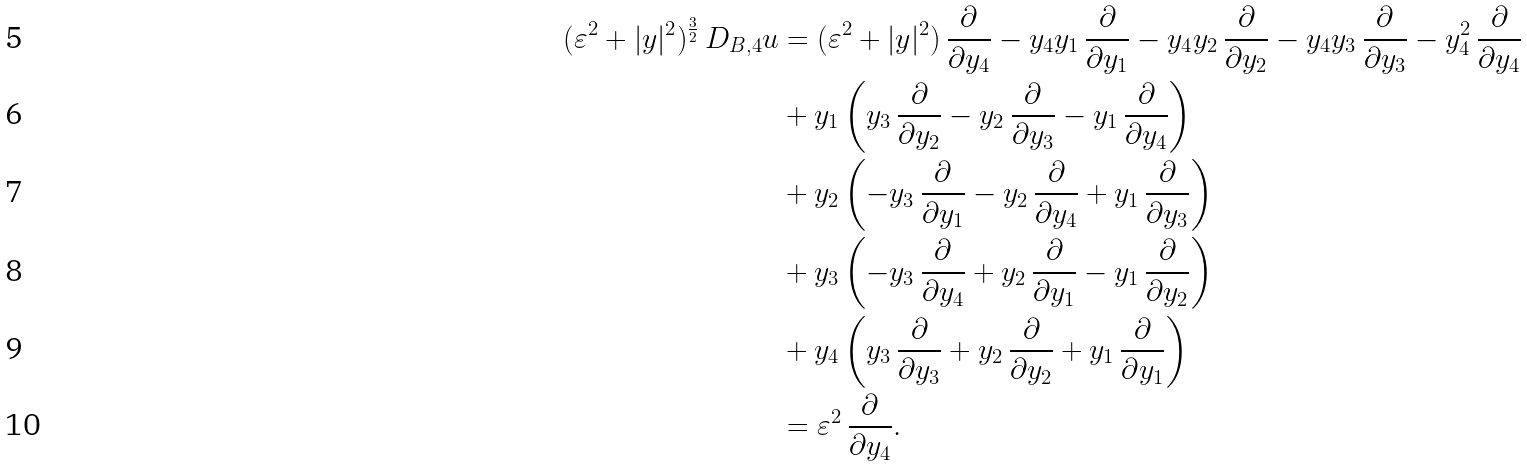Convert formula to latex. <formula><loc_0><loc_0><loc_500><loc_500>( \varepsilon ^ { 2 } + | y | ^ { 2 } ) ^ { \frac { 3 } { 2 } } \, D _ { B , 4 } u & = ( \varepsilon ^ { 2 } + | y | ^ { 2 } ) \, \frac { \partial } { \partial y _ { 4 } } - y _ { 4 } y _ { 1 } \, \frac { \partial } { \partial y _ { 1 } } - y _ { 4 } y _ { 2 } \, \frac { \partial } { \partial y _ { 2 } } - y _ { 4 } y _ { 3 } \, \frac { \partial } { \partial y _ { 3 } } - y _ { 4 } ^ { 2 } \, \frac { \partial } { \partial y _ { 4 } } \\ & + y _ { 1 } \left ( y _ { 3 } \, \frac { \partial } { \partial y _ { 2 } } - y _ { 2 } \, \frac { \partial } { \partial y _ { 3 } } - y _ { 1 } \, \frac { \partial } { \partial y _ { 4 } } \right ) \\ & + y _ { 2 } \left ( - y _ { 3 } \, \frac { \partial } { \partial y _ { 1 } } - y _ { 2 } \, \frac { \partial } { \partial y _ { 4 } } + y _ { 1 } \, \frac { \partial } { \partial y _ { 3 } } \right ) \\ & + y _ { 3 } \left ( - y _ { 3 } \, \frac { \partial } { \partial y _ { 4 } } + y _ { 2 } \, \frac { \partial } { \partial y _ { 1 } } - y _ { 1 } \, \frac { \partial } { \partial y _ { 2 } } \right ) \\ & + y _ { 4 } \left ( y _ { 3 } \, \frac { \partial } { \partial y _ { 3 } } + y _ { 2 } \, \frac { \partial } { \partial y _ { 2 } } + y _ { 1 } \, \frac { \partial } { \partial y _ { 1 } } \right ) \\ & = \varepsilon ^ { 2 } \, \frac { \partial } { \partial y _ { 4 } } .</formula> 